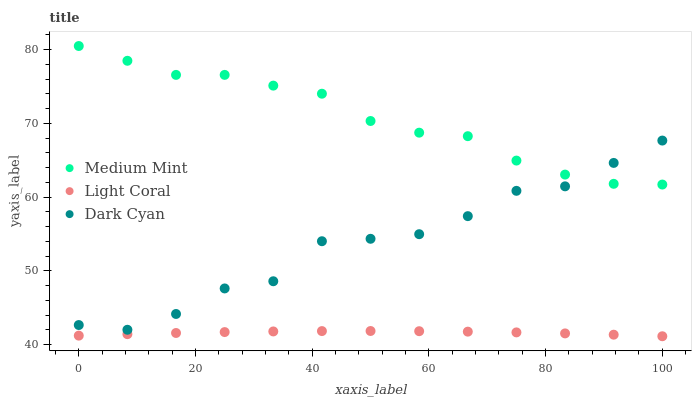Does Light Coral have the minimum area under the curve?
Answer yes or no. Yes. Does Medium Mint have the maximum area under the curve?
Answer yes or no. Yes. Does Dark Cyan have the minimum area under the curve?
Answer yes or no. No. Does Dark Cyan have the maximum area under the curve?
Answer yes or no. No. Is Light Coral the smoothest?
Answer yes or no. Yes. Is Dark Cyan the roughest?
Answer yes or no. Yes. Is Dark Cyan the smoothest?
Answer yes or no. No. Is Light Coral the roughest?
Answer yes or no. No. Does Light Coral have the lowest value?
Answer yes or no. Yes. Does Dark Cyan have the lowest value?
Answer yes or no. No. Does Medium Mint have the highest value?
Answer yes or no. Yes. Does Dark Cyan have the highest value?
Answer yes or no. No. Is Light Coral less than Medium Mint?
Answer yes or no. Yes. Is Medium Mint greater than Light Coral?
Answer yes or no. Yes. Does Medium Mint intersect Dark Cyan?
Answer yes or no. Yes. Is Medium Mint less than Dark Cyan?
Answer yes or no. No. Is Medium Mint greater than Dark Cyan?
Answer yes or no. No. Does Light Coral intersect Medium Mint?
Answer yes or no. No. 